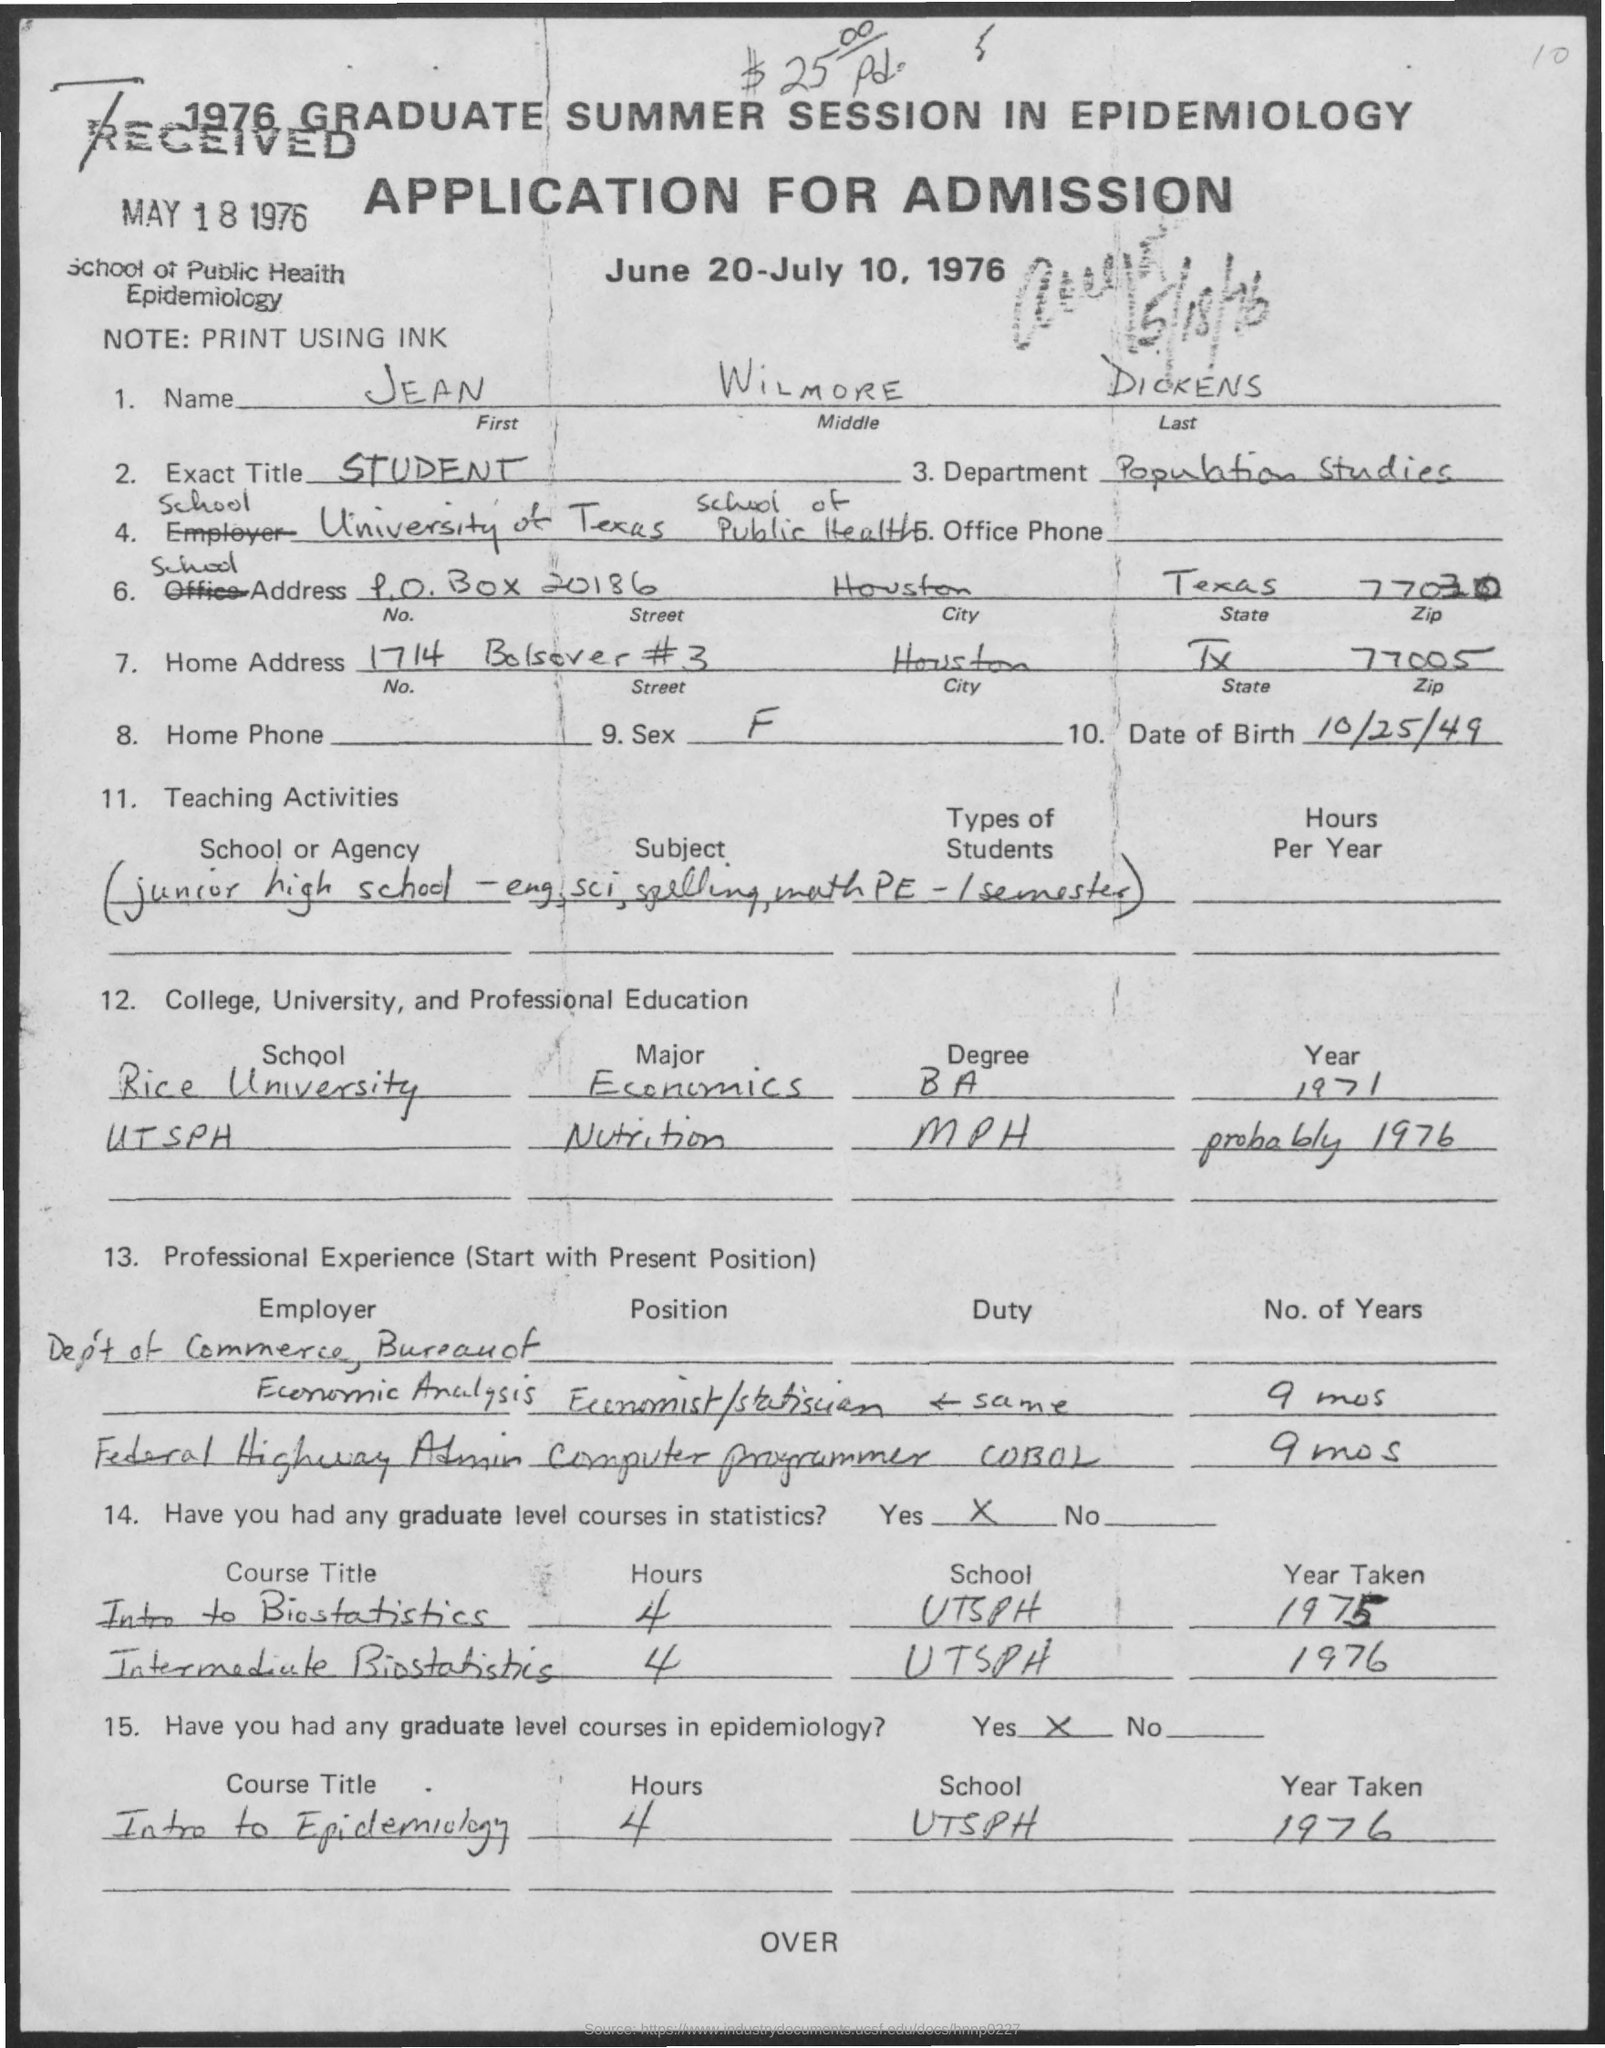List a handful of essential elements in this visual. The date on which the application was received was May 18, 1976. The date of birth mentioned in the given application is October 25, 1949. The exact title mentioned in the given application is STUDENT. The note mentioned in the given application is PRINT USING INK. What is the ZIP code for the home address mentioned in the given application? 77005... 